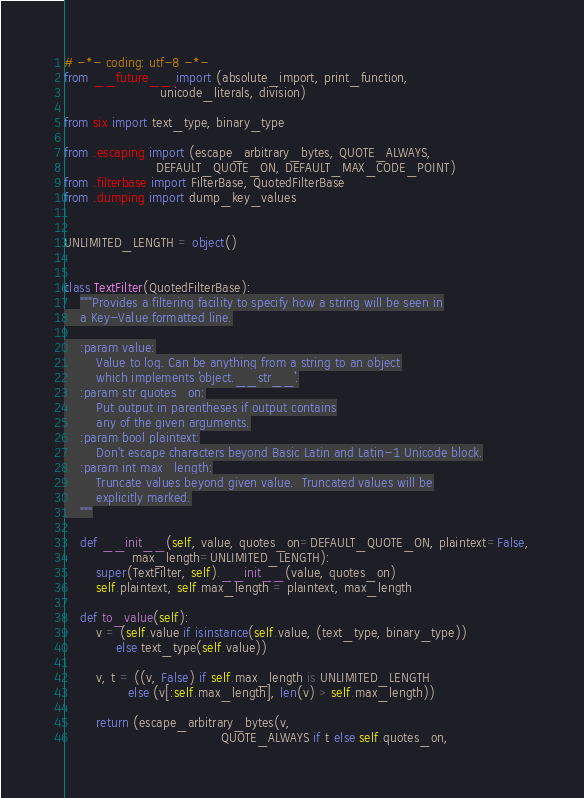<code> <loc_0><loc_0><loc_500><loc_500><_Python_># -*- coding: utf-8 -*-
from __future__ import (absolute_import, print_function,
                        unicode_literals, division)

from six import text_type, binary_type

from .escaping import (escape_arbitrary_bytes, QUOTE_ALWAYS,
                       DEFAULT_QUOTE_ON, DEFAULT_MAX_CODE_POINT)
from .filterbase import FilterBase, QuotedFilterBase
from .dumping import dump_key_values


UNLIMITED_LENGTH = object()


class TextFilter(QuotedFilterBase):
    """Provides a filtering facility to specify how a string will be seen in
    a Key-Value formatted line.

    :param value:
        Value to log. Can be anything from a string to an object
        which implements ``object.__str__``.
    :param str quotes_on:
        Put output in parentheses if output contains
        any of the given arguments.
    :param bool plaintext:
        Don't escape characters beyond Basic Latin and Latin-1 Unicode block.
    :param int max_length:
        Truncate values beyond given value.  Truncated values will be
        explicitly marked.
    """

    def __init__(self, value, quotes_on=DEFAULT_QUOTE_ON, plaintext=False,
                 max_length=UNLIMITED_LENGTH):
        super(TextFilter, self).__init__(value, quotes_on)
        self.plaintext, self.max_length = plaintext, max_length

    def to_value(self):
        v = (self.value if isinstance(self.value, (text_type, binary_type))
             else text_type(self.value))

        v, t = ((v, False) if self.max_length is UNLIMITED_LENGTH
                else (v[:self.max_length], len(v) > self.max_length))

        return (escape_arbitrary_bytes(v,
                                       QUOTE_ALWAYS if t else self.quotes_on,</code> 